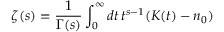Convert formula to latex. <formula><loc_0><loc_0><loc_500><loc_500>\zeta ( s ) = { \frac { 1 } { \Gamma ( s ) } } \int _ { 0 } ^ { \infty } d t \, t ^ { s - 1 } ( K ( t ) - n _ { 0 } )</formula> 